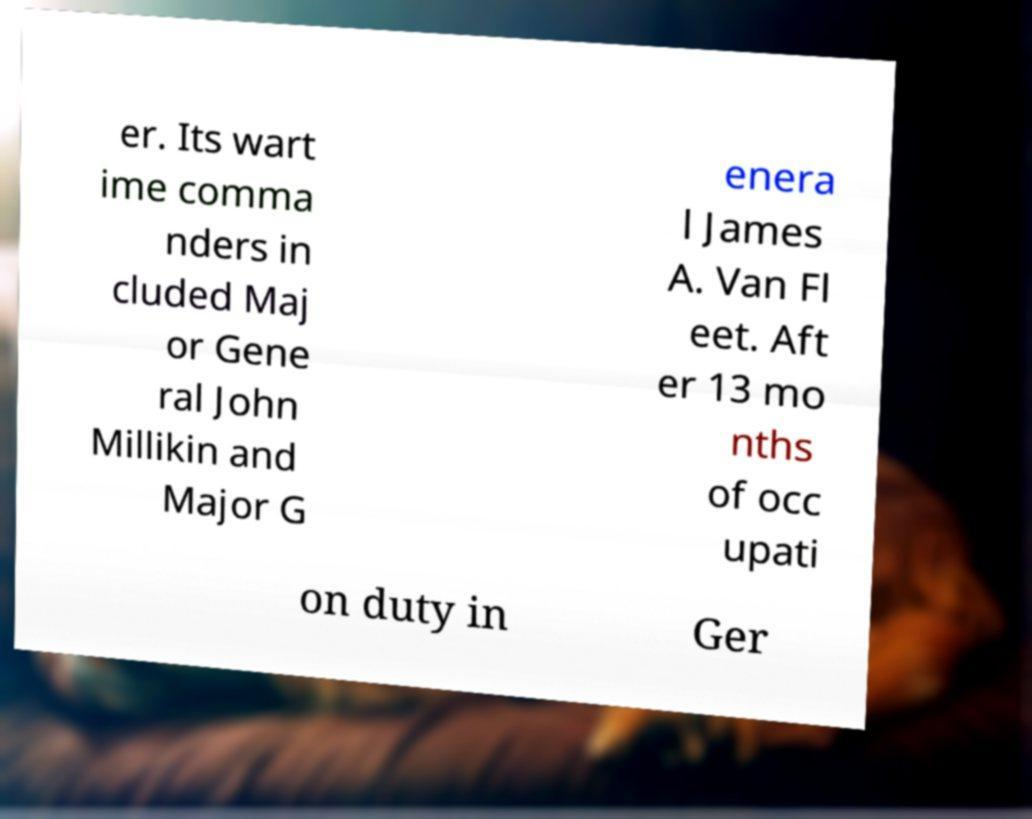There's text embedded in this image that I need extracted. Can you transcribe it verbatim? er. Its wart ime comma nders in cluded Maj or Gene ral John Millikin and Major G enera l James A. Van Fl eet. Aft er 13 mo nths of occ upati on duty in Ger 